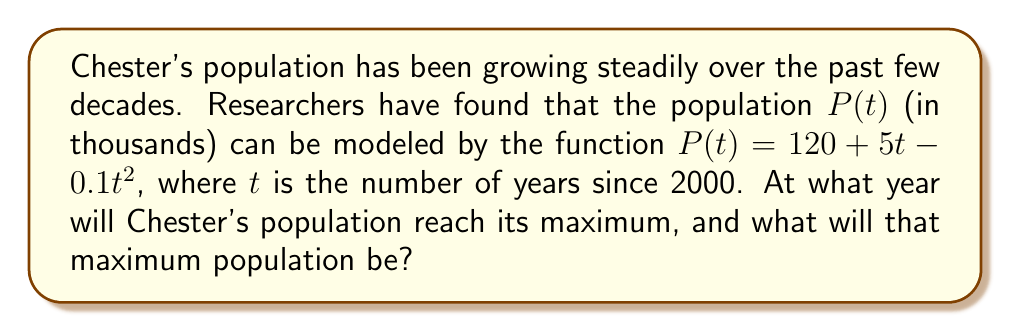Show me your answer to this math problem. To solve this problem, we'll follow these steps:

1) The population function is given by:
   $$P(t) = 120 + 5t - 0.1t^2$$

2) To find the maximum, we need to find the vertex of this parabola. We can do this by finding where the derivative equals zero.

3) Let's find the derivative:
   $$P'(t) = 5 - 0.2t$$

4) Set the derivative to zero and solve for t:
   $$5 - 0.2t = 0$$
   $$-0.2t = -5$$
   $$t = 25$$

5) This means the population will reach its maximum 25 years after 2000, which is in the year 2025.

6) To find the maximum population, we substitute t = 25 into the original function:
   $$P(25) = 120 + 5(25) - 0.1(25)^2$$
   $$= 120 + 125 - 0.1(625)$$
   $$= 245 - 62.5$$
   $$= 182.5$$

7) Therefore, the maximum population will be 182,500 people.
Answer: Year 2025; 182,500 people 